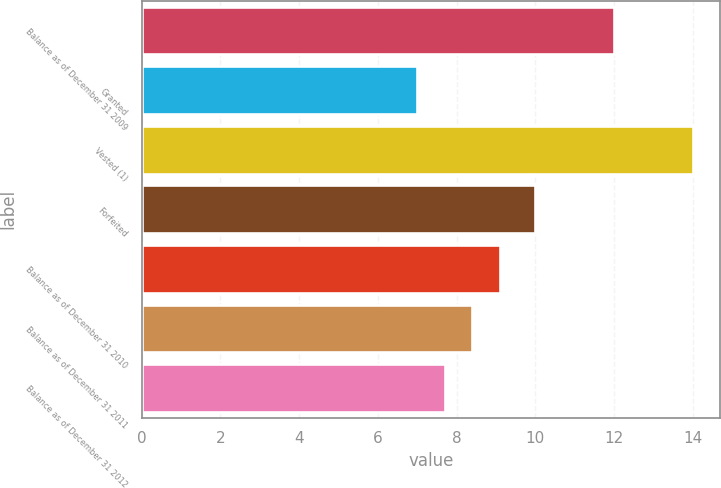Convert chart. <chart><loc_0><loc_0><loc_500><loc_500><bar_chart><fcel>Balance as of December 31 2009<fcel>Granted<fcel>Vested (1)<fcel>Forfeited<fcel>Balance as of December 31 2010<fcel>Balance as of December 31 2011<fcel>Balance as of December 31 2012<nl><fcel>12<fcel>7<fcel>14<fcel>10<fcel>9.1<fcel>8.4<fcel>7.7<nl></chart> 